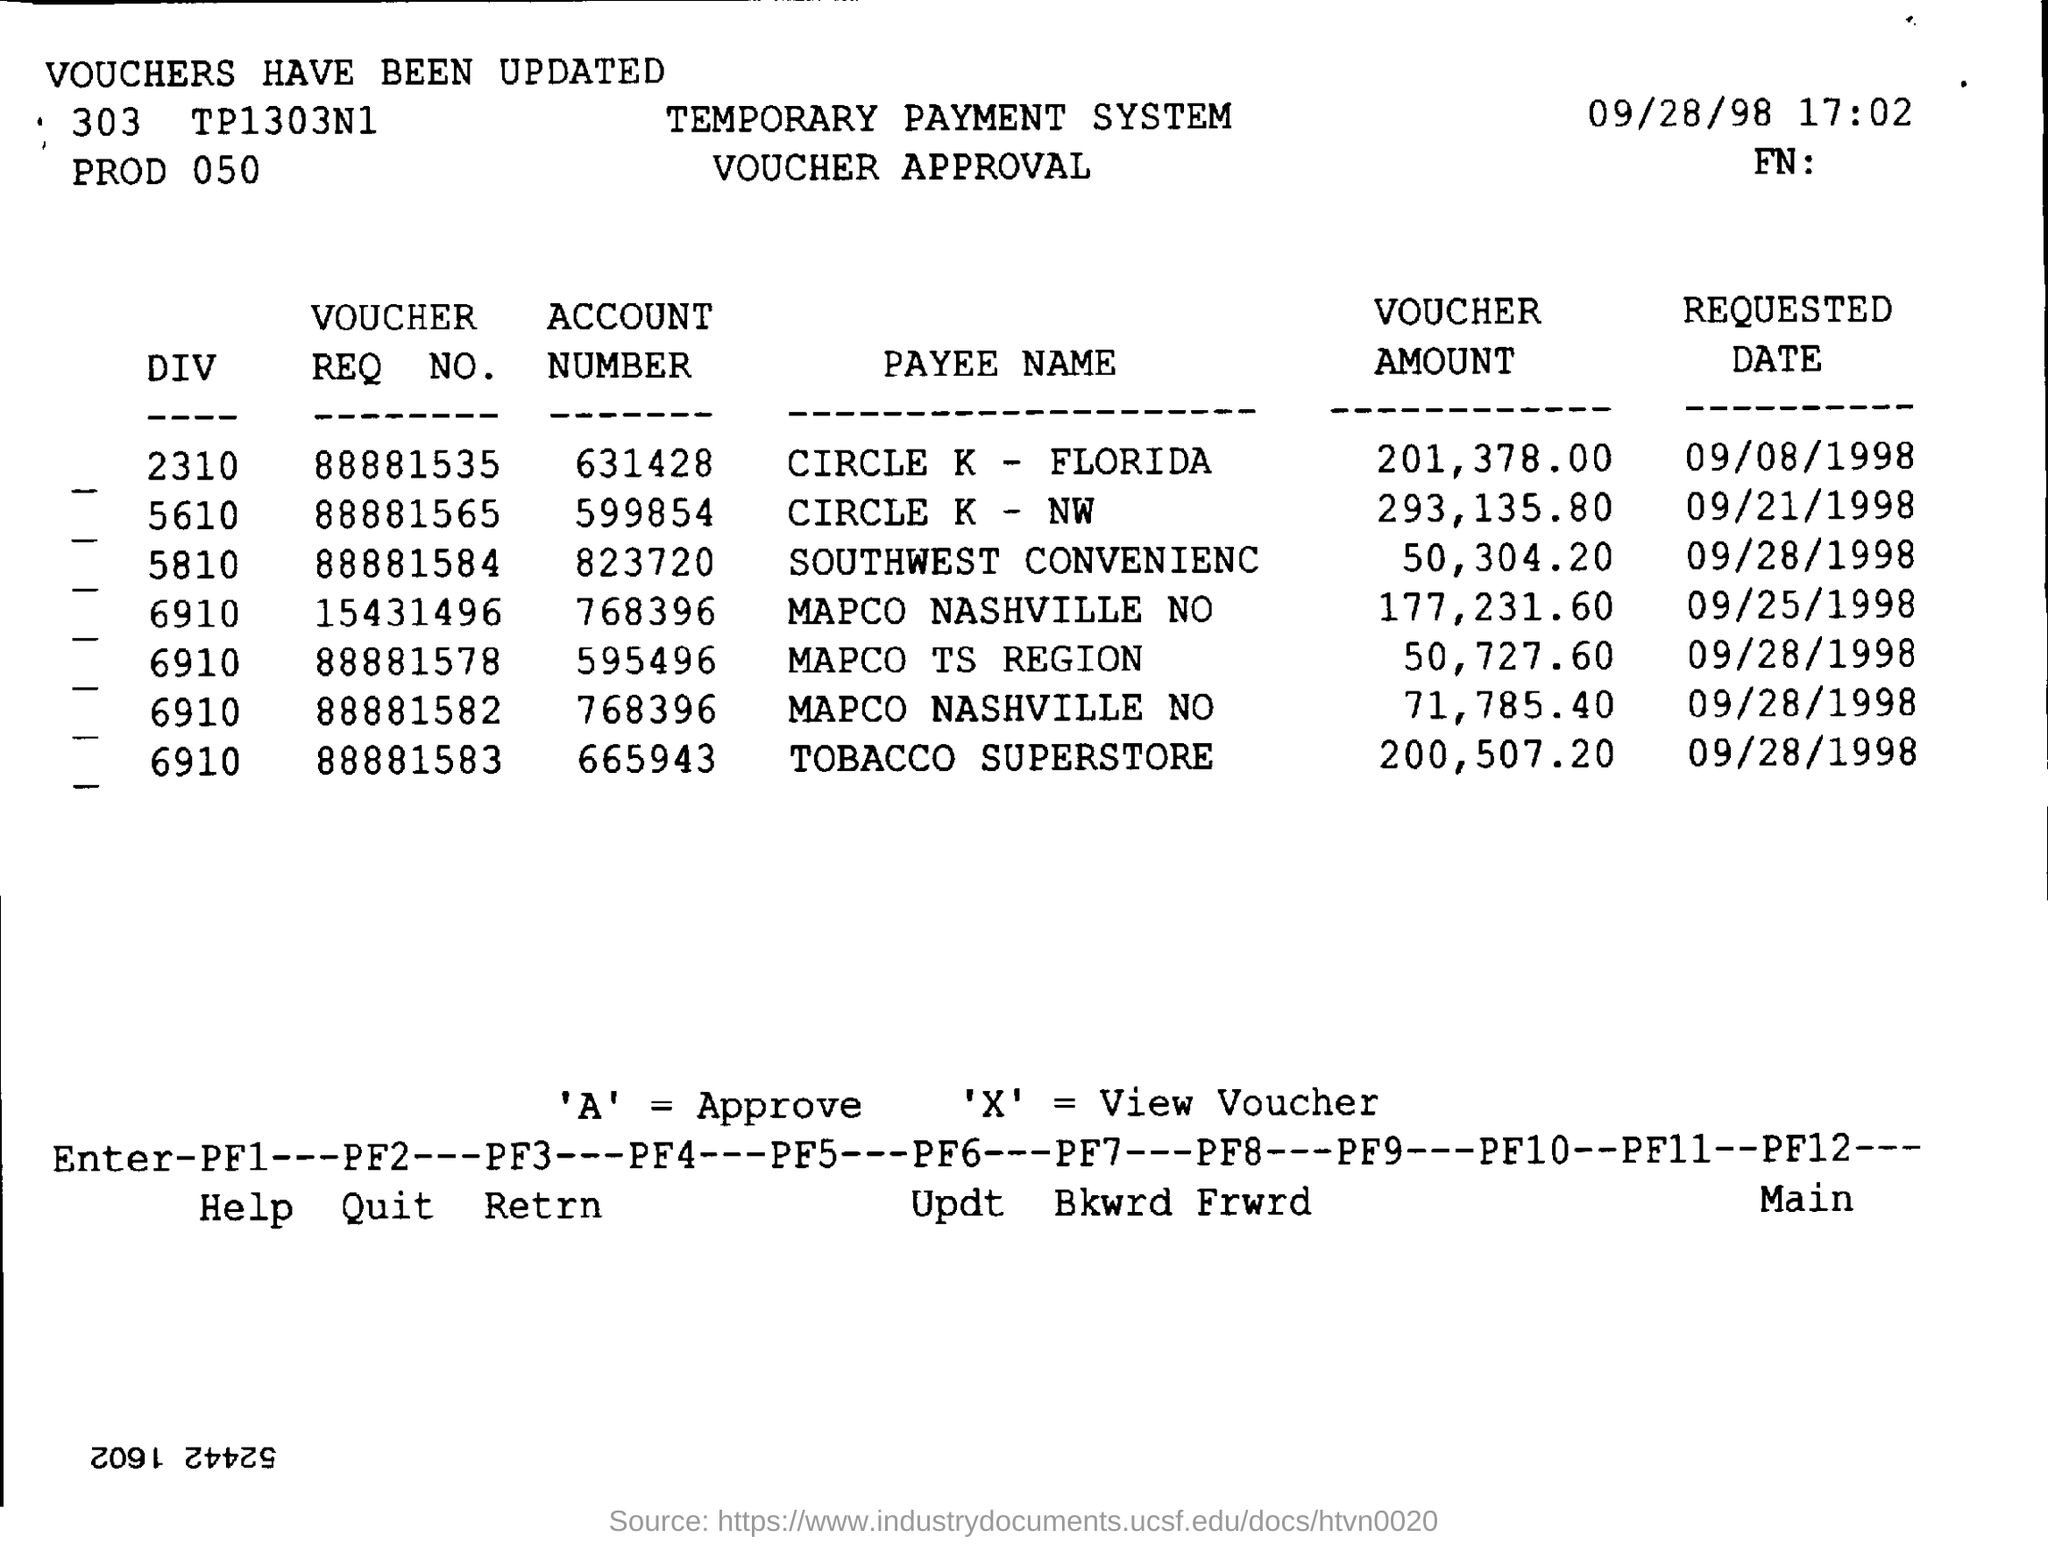What is the Account Number of CIRCLE  K - FLORIDA?
Ensure brevity in your answer.  631428. What does 'A' indicate ?
Keep it short and to the point. Approve. What does 'X' indicate ?
Make the answer very short. View voucher. What is the Voucher Amount of TOBACCO SUPERSTORE ?
Your answer should be compact. 200,507.20. What is the requested date for the account number 599854 ?
Keep it short and to the point. 09/21/1998. 